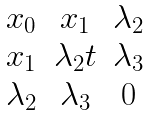<formula> <loc_0><loc_0><loc_500><loc_500>\begin{matrix} x _ { 0 } & x _ { 1 } & \lambda _ { 2 } \\ x _ { 1 } & \lambda _ { 2 } t & \lambda _ { 3 } \\ \lambda _ { 2 } & \lambda _ { 3 } & 0 \\ \end{matrix}</formula> 